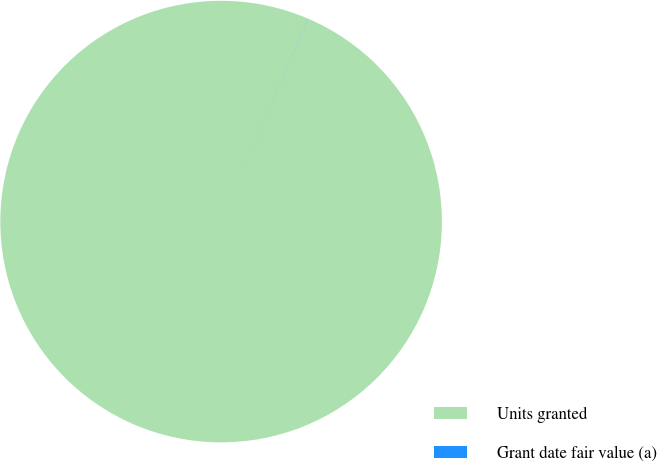Convert chart to OTSL. <chart><loc_0><loc_0><loc_500><loc_500><pie_chart><fcel>Units granted<fcel>Grant date fair value (a)<nl><fcel>99.99%<fcel>0.01%<nl></chart> 